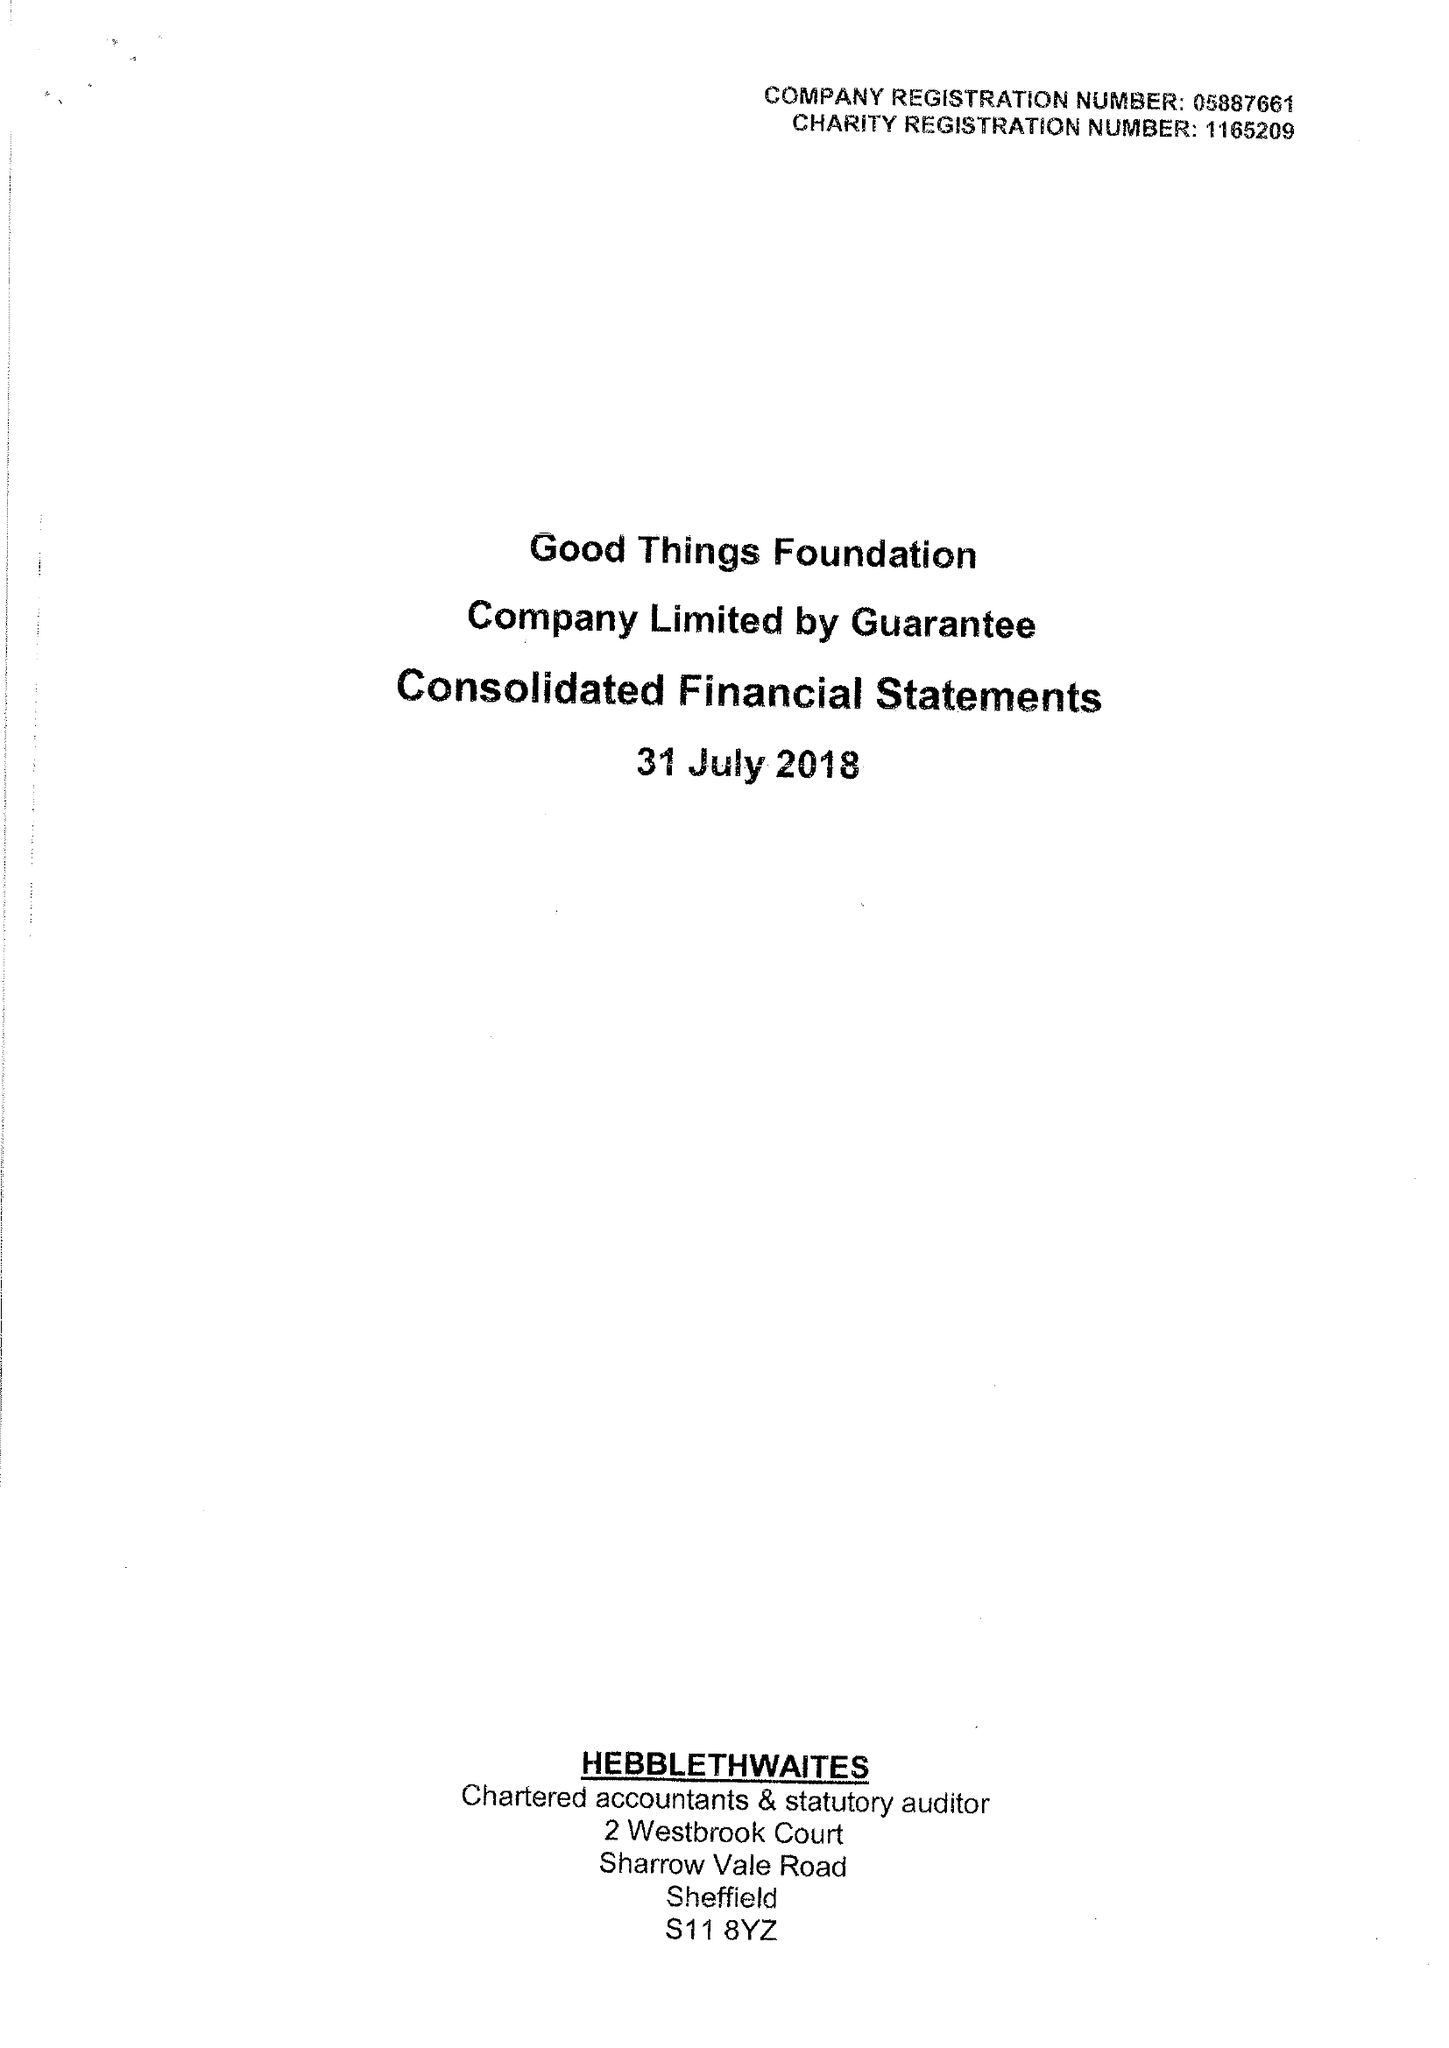What is the value for the report_date?
Answer the question using a single word or phrase. 2018-07-31 